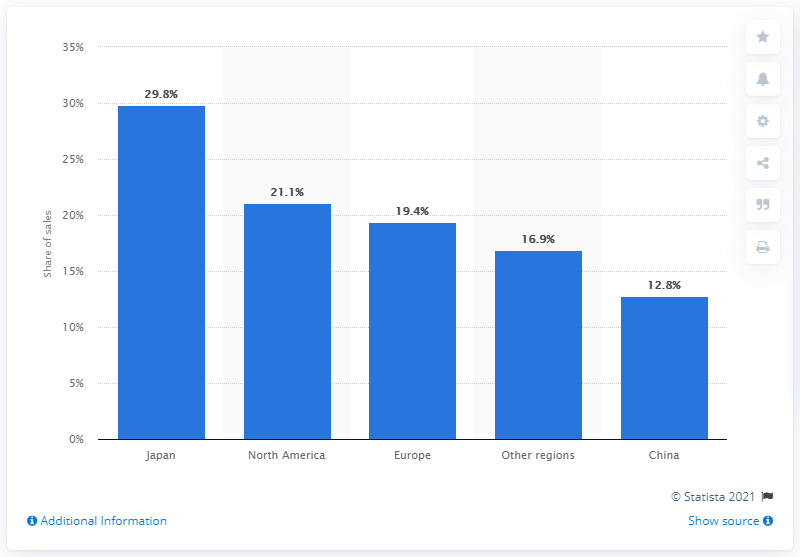Mention a couple of crucial points in this snapshot. The maximum sales share and the average sales share are two different measures of a product's performance in terms of sales. The maximum sales share refers to the highest percentage of sales that a product has ever achieved, while the average sales share refers to the percentage of sales that a product has typically achieved over a certain period of time. For example, if a product has a maximum sales share of 9.8% and an average sales share of 4.5%, this could indicate that the product has had some strong sales periods but has not consistently performed well overall. The second leftmost bar has a value of 21.1... In 2019, approximately 29.8% of Yamaha's total sales were generated in Japan. 